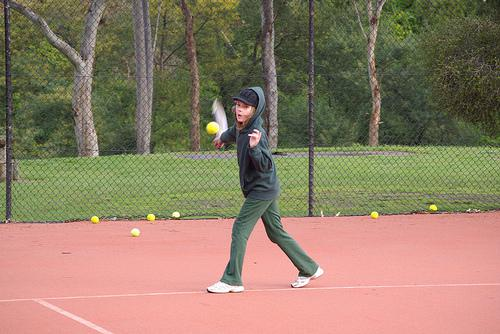Question: what color is the tennis court?
Choices:
A. Green.
B. Brown.
C. Maroon.
D. Pink.
Answer with the letter. Answer: D Question: how many balls are in the picture?
Choices:
A. 6.
B. 5.
C. 7.
D. 4.
Answer with the letter. Answer: C 